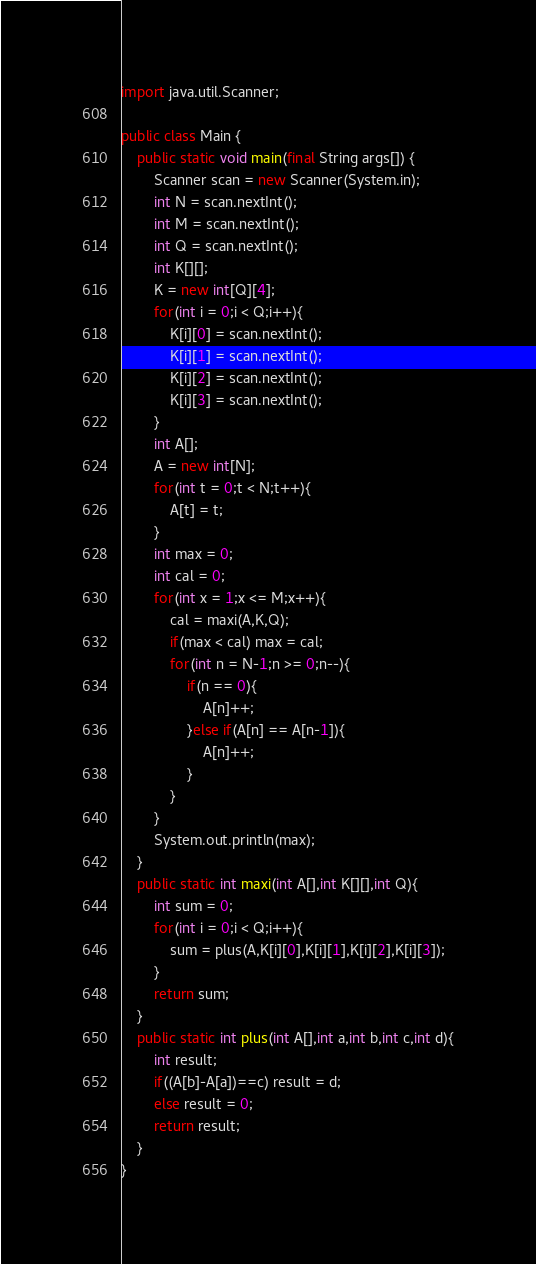Convert code to text. <code><loc_0><loc_0><loc_500><loc_500><_Java_>import java.util.Scanner;

public class Main {
    public static void main(final String args[]) {
        Scanner scan = new Scanner(System.in);
        int N = scan.nextInt();
        int M = scan.nextInt();
        int Q = scan.nextInt();
        int K[][];
        K = new int[Q][4];
        for(int i = 0;i < Q;i++){
            K[i][0] = scan.nextInt();
            K[i][1] = scan.nextInt();
            K[i][2] = scan.nextInt();
            K[i][3] = scan.nextInt();
        }
        int A[];
        A = new int[N];
        for(int t = 0;t < N;t++){
            A[t] = t;
        }
        int max = 0;
        int cal = 0;
        for(int x = 1;x <= M;x++){
            cal = maxi(A,K,Q);
            if(max < cal) max = cal;
            for(int n = N-1;n >= 0;n--){
                if(n == 0){
                    A[n]++;
                }else if(A[n] == A[n-1]){
                    A[n]++;
                }
            }
        }
        System.out.println(max);
    }
    public static int maxi(int A[],int K[][],int Q){
        int sum = 0;
        for(int i = 0;i < Q;i++){
            sum = plus(A,K[i][0],K[i][1],K[i][2],K[i][3]);
        }
        return sum;
    }
    public static int plus(int A[],int a,int b,int c,int d){
        int result;
        if((A[b]-A[a])==c) result = d;
        else result = 0;
        return result;
    }
}
</code> 